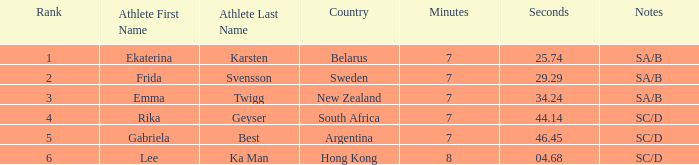What is the race time for emma twigg? 7:34.24. 